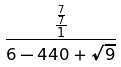Convert formula to latex. <formula><loc_0><loc_0><loc_500><loc_500>\frac { \frac { \frac { 7 } { 7 } } { 1 } } { 6 - 4 4 0 + \sqrt { 9 } }</formula> 